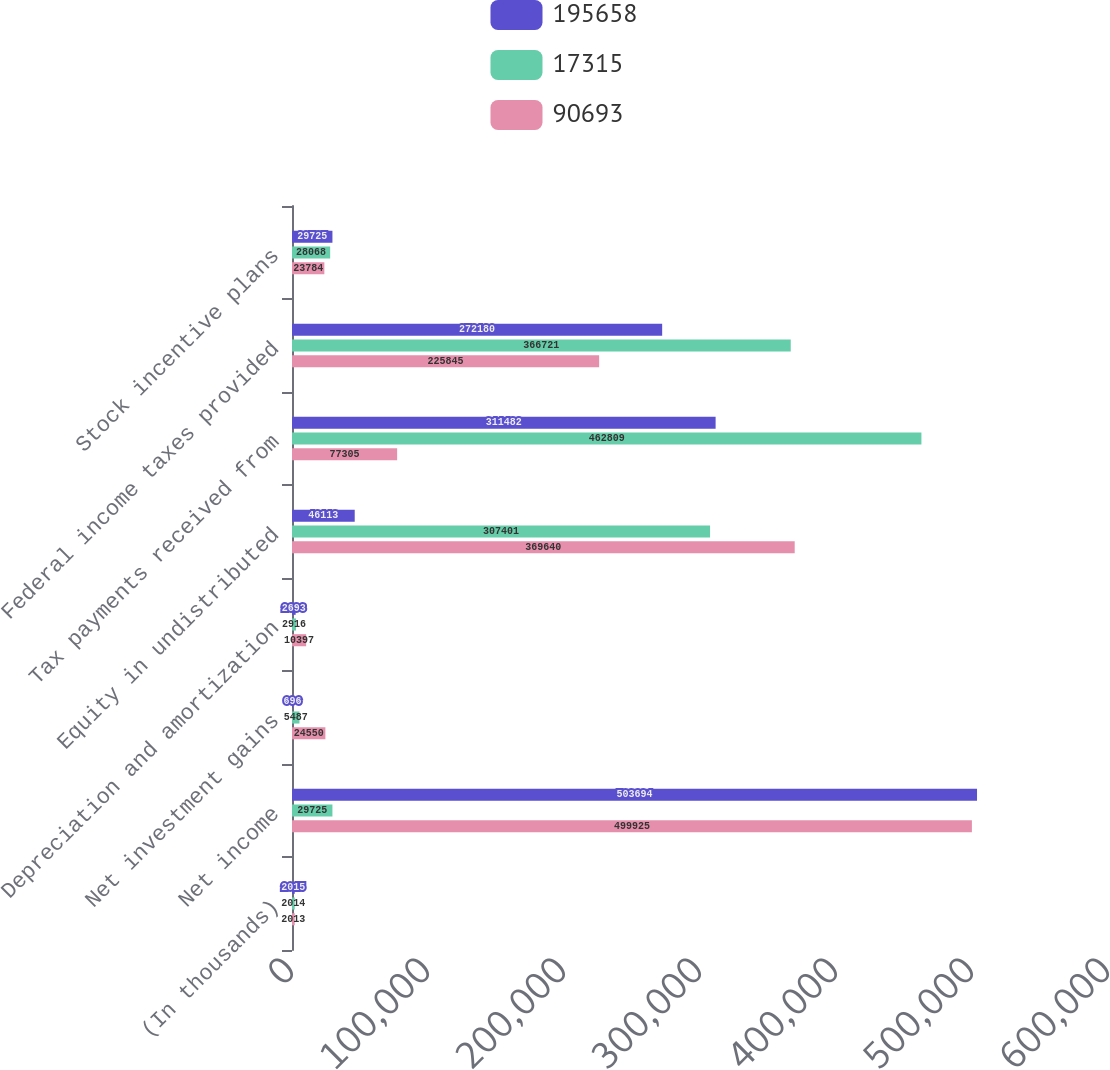<chart> <loc_0><loc_0><loc_500><loc_500><stacked_bar_chart><ecel><fcel>(In thousands)<fcel>Net income<fcel>Net investment gains<fcel>Depreciation and amortization<fcel>Equity in undistributed<fcel>Tax payments received from<fcel>Federal income taxes provided<fcel>Stock incentive plans<nl><fcel>195658<fcel>2015<fcel>503694<fcel>696<fcel>2693<fcel>46113<fcel>311482<fcel>272180<fcel>29725<nl><fcel>17315<fcel>2014<fcel>29725<fcel>5487<fcel>2916<fcel>307401<fcel>462809<fcel>366721<fcel>28068<nl><fcel>90693<fcel>2013<fcel>499925<fcel>24550<fcel>10397<fcel>369640<fcel>77305<fcel>225845<fcel>23784<nl></chart> 